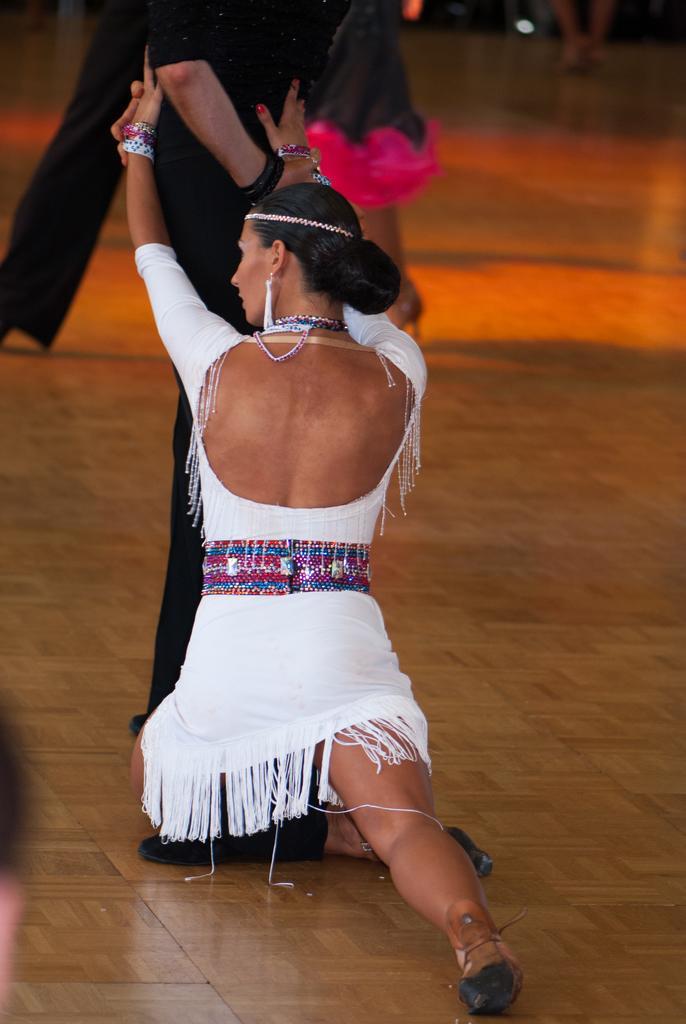In one or two sentences, can you explain what this image depicts? In this image I can see a group of people are performing a dance on the floor and lights. This image is taken may be in a hall. 